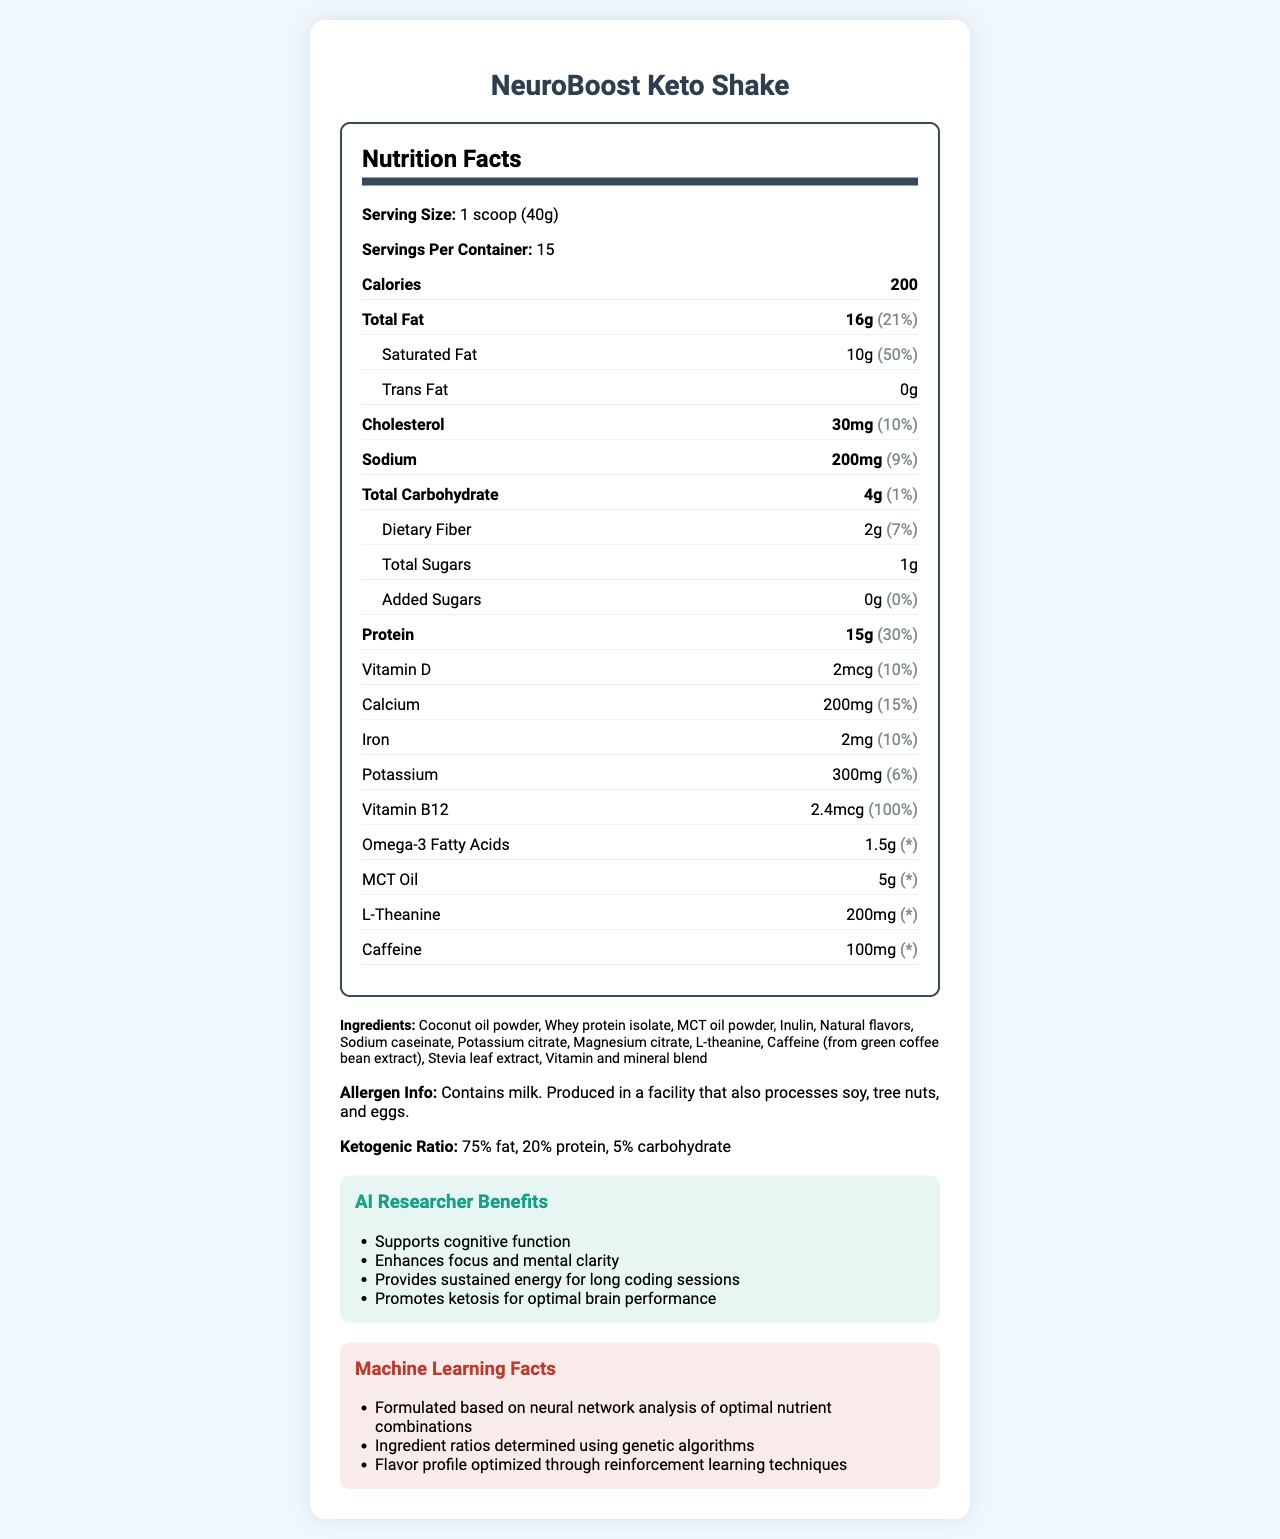what is the serving size? The serving size is explicitly listed at the beginning of the Nutrition Facts section, under "Serving Size."
Answer: 1 scoop (40g) how many servings are in one container? The document notes the number of servings per container as 15.
Answer: 15 what is the amount of total fat per serving? The total fat amount is highlighted in the Nutrition Facts under "Total Fat."
Answer: 16g how much saturated fat is in each serving? The saturated fat amount is listed as a sub-item under "Total Fat."
Answer: 10g how much protein is in one serving? The protein amount is given in the Nutrition Facts section under "Protein."
Answer: 15g does the product contain any added sugars? The Nutrition Facts section specifies 0g of added sugars.
Answer: No, 0g what is the daily value percentage of vitamin B12? The daily value percentage for vitamin B12 is listed as 100%.
Answer: 100% how much caffeine does each serving contain? A. 200mg B. 100mg C. 50mg D. 10mg The amount of caffeine per serving is provided in the Nutrition Facts section under "Caffeine," which states 100mg.
Answer: B. 100mg which ingredient is not listed in the product? A. Stevia leaf extract B. Sodium caseinate C. MCT oil powder D. Sugar The ingredients list shows Stevia leaf extract, Sodium caseinate, MCT oil powder, but not sugar.
Answer: D. Sugar is this product suitable for someone with a tree nut allergy? The allergen information states it is "Produced in a facility that also processes soy, tree nuts, and eggs."
Answer: No what benefits does this shake offer to AI researchers? The benefits for AI researchers are listed in the "AI Researcher Benefits" section.
Answer: Supports cognitive function, Enhances focus and mental clarity, Provides sustained energy for long coding sessions, Promotes ketosis for optimal brain performance what is the main idea of this document? The document offers comprehensive data on the product's nutritional content, targeting AI researchers with specific cognitive benefits and insights into its formulation methods.
Answer: The document provides detailed nutritional information about the NeuroBoost Keto Shake, emphasizing its high-fat, low-carb composition, tailored for AI researchers to support cognitive function, with additional details on ingredients, allergen information, and ketogenic ratio. what is the source of caffeine in this product? The document states caffeine is included, but it doesn't specify the source within the standard Nutrition Facts section. However, the ingredients list does mention "Caffeine (from green coffee bean extract)," but this is outside the primary context of the Nutrition Facts.
Answer: Not enough information 